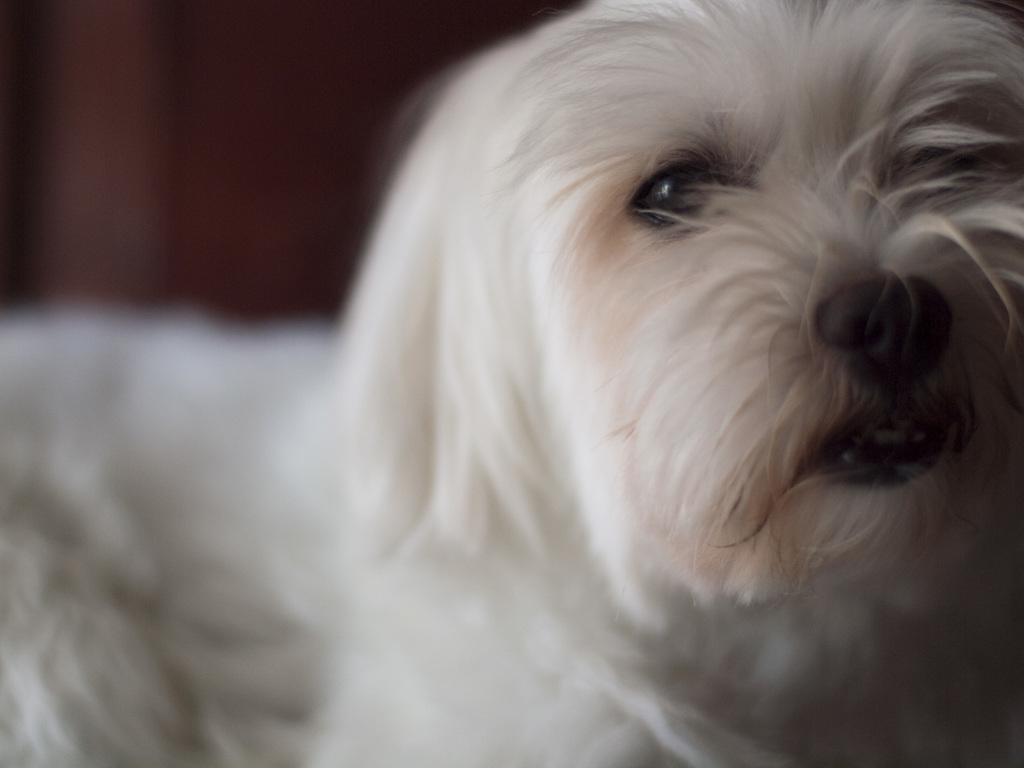What type of animal is present in the image? There is a dog in the image. Can you describe the color of the dog? The dog is white in color. What type of juice is the dog drinking in the image? There is: There is no juice present in the image, and the dog is not shown drinking anything. 